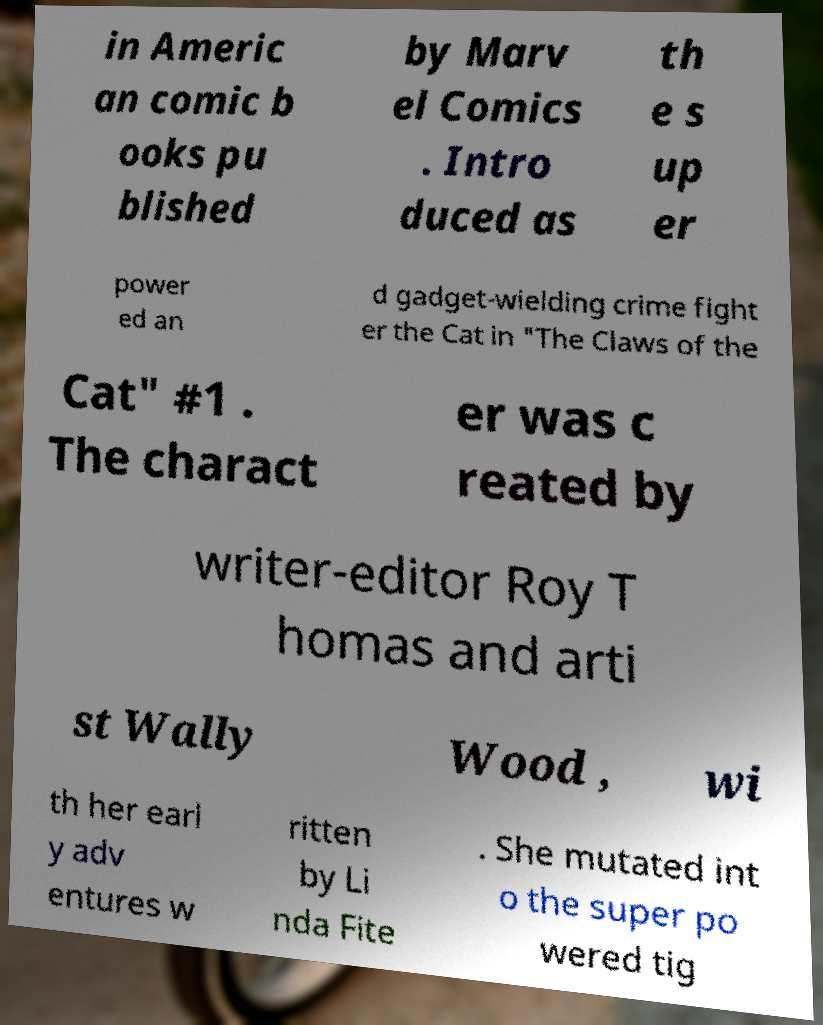What messages or text are displayed in this image? I need them in a readable, typed format. in Americ an comic b ooks pu blished by Marv el Comics . Intro duced as th e s up er power ed an d gadget-wielding crime fight er the Cat in "The Claws of the Cat" #1 . The charact er was c reated by writer-editor Roy T homas and arti st Wally Wood , wi th her earl y adv entures w ritten by Li nda Fite . She mutated int o the super po wered tig 